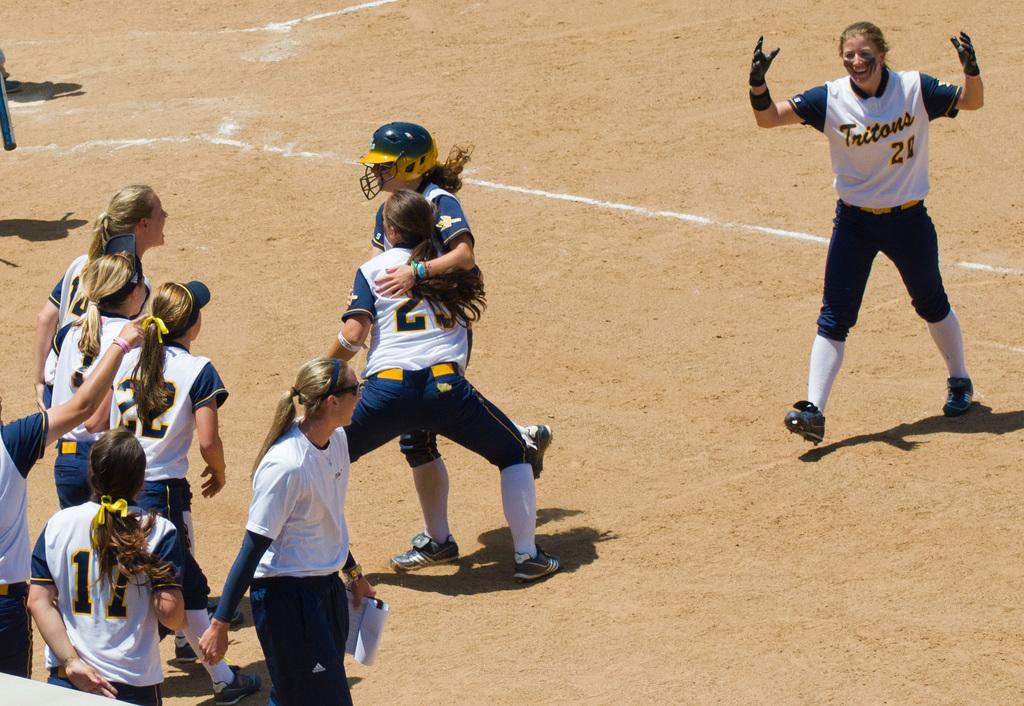What is the name of this team?
Make the answer very short. Tritons. 